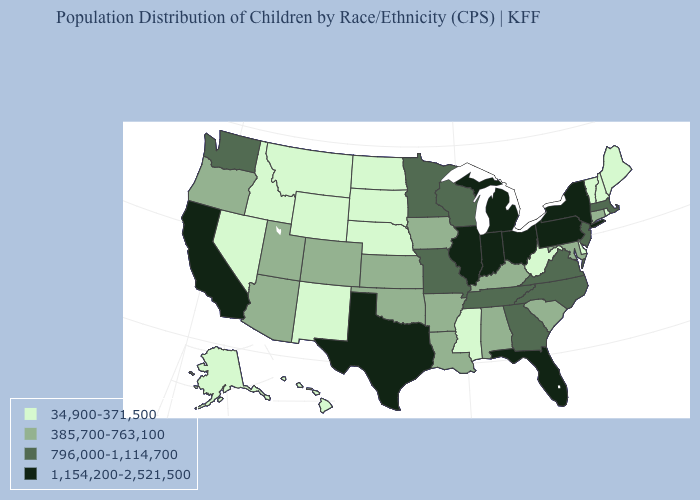What is the value of Massachusetts?
Short answer required. 796,000-1,114,700. Does South Dakota have the lowest value in the MidWest?
Write a very short answer. Yes. Which states have the lowest value in the MidWest?
Answer briefly. Nebraska, North Dakota, South Dakota. What is the value of Indiana?
Concise answer only. 1,154,200-2,521,500. Among the states that border South Dakota , which have the highest value?
Quick response, please. Minnesota. Which states have the highest value in the USA?
Keep it brief. California, Florida, Illinois, Indiana, Michigan, New York, Ohio, Pennsylvania, Texas. Which states have the lowest value in the USA?
Keep it brief. Alaska, Delaware, Hawaii, Idaho, Maine, Mississippi, Montana, Nebraska, Nevada, New Hampshire, New Mexico, North Dakota, Rhode Island, South Dakota, Vermont, West Virginia, Wyoming. What is the lowest value in the South?
Quick response, please. 34,900-371,500. What is the lowest value in the USA?
Be succinct. 34,900-371,500. What is the value of Wyoming?
Be succinct. 34,900-371,500. Does Florida have a lower value than Illinois?
Concise answer only. No. What is the highest value in the MidWest ?
Quick response, please. 1,154,200-2,521,500. Name the states that have a value in the range 385,700-763,100?
Write a very short answer. Alabama, Arizona, Arkansas, Colorado, Connecticut, Iowa, Kansas, Kentucky, Louisiana, Maryland, Oklahoma, Oregon, South Carolina, Utah. Which states have the highest value in the USA?
Short answer required. California, Florida, Illinois, Indiana, Michigan, New York, Ohio, Pennsylvania, Texas. 